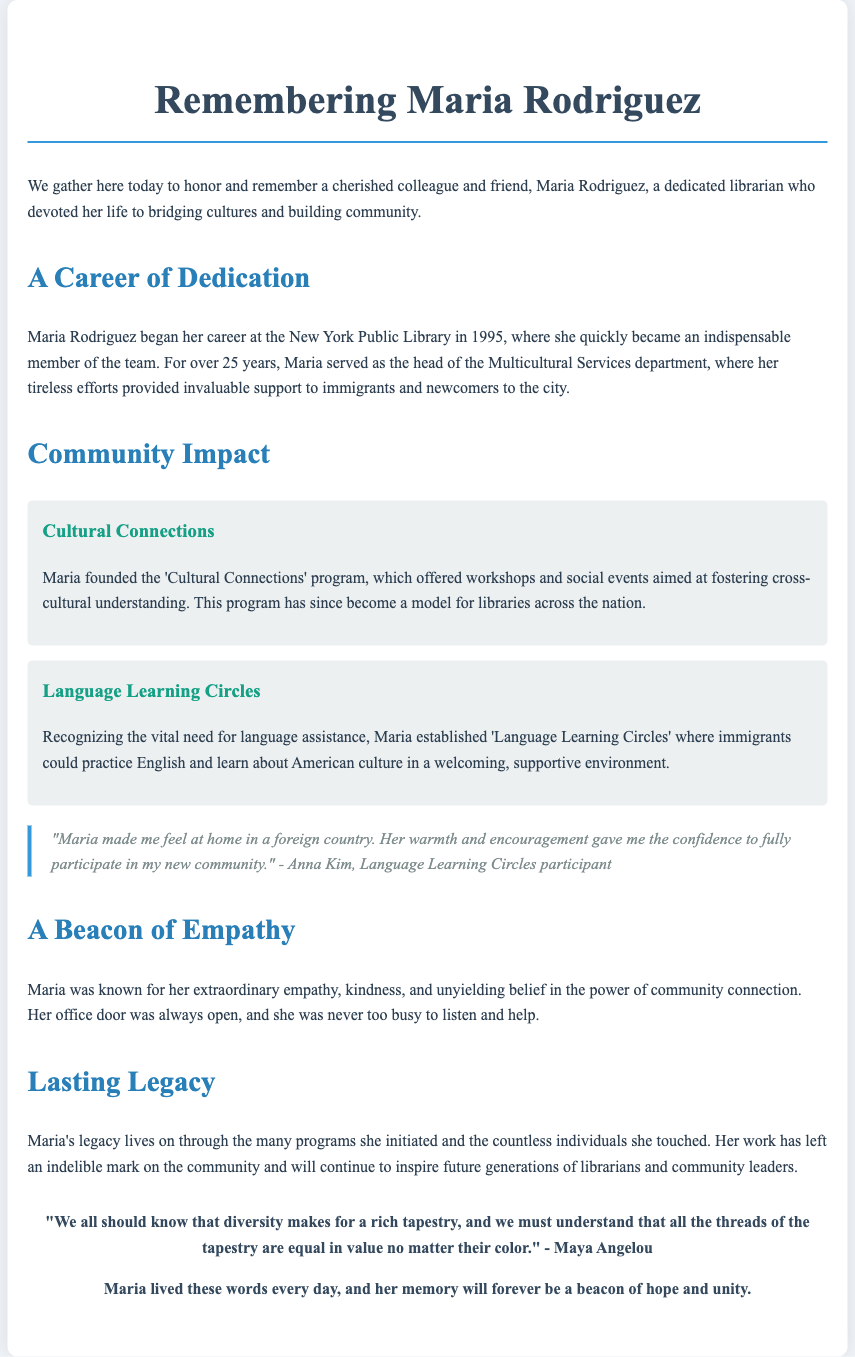What year did Maria Rodriguez begin her career? Maria began her career at the New York Public Library in 1995.
Answer: 1995 What program did Maria found to foster cross-cultural understanding? The document mentions that Maria founded the 'Cultural Connections' program.
Answer: Cultural Connections How many years did Maria serve at the New York Public Library? Maria served for over 25 years at the New York Public Library, starting in 1995.
Answer: 25 years What did Maria establish to assist immigrants in practicing English? The document states Maria established 'Language Learning Circles' for this purpose.
Answer: Language Learning Circles What quote from Anna Kim reflects Maria's impact on newcomers? Anna Kim mentioned, "Maria made me feel at home in a foreign country."
Answer: "Maria made me feel at home in a foreign country." What two qualities was Maria particularly known for? Maria was known for her extraordinary empathy and kindness.
Answer: Empathy and kindness How does the document describe Maria's office? The document states that her office door was always open.
Answer: Always open What does Maya Angelou’s quote in the document emphasize? The quote emphasizes the value of diversity and equality among all people.
Answer: Diversity and equality 